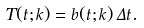Convert formula to latex. <formula><loc_0><loc_0><loc_500><loc_500>T ( t ; k ) = b ( t ; k ) \, \Delta t .</formula> 